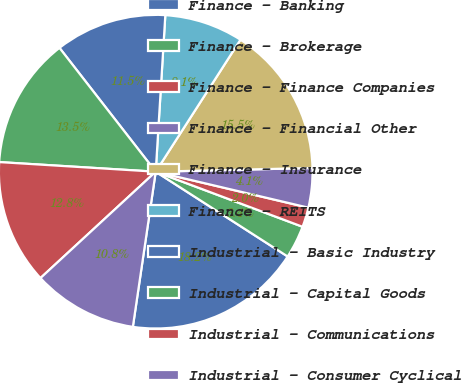<chart> <loc_0><loc_0><loc_500><loc_500><pie_chart><fcel>Finance - Banking<fcel>Finance - Brokerage<fcel>Finance - Finance Companies<fcel>Finance - Financial Other<fcel>Finance - Insurance<fcel>Finance - REITS<fcel>Industrial - Basic Industry<fcel>Industrial - Capital Goods<fcel>Industrial - Communications<fcel>Industrial - Consumer Cyclical<nl><fcel>18.24%<fcel>3.38%<fcel>2.03%<fcel>4.06%<fcel>15.54%<fcel>8.11%<fcel>11.49%<fcel>13.51%<fcel>12.84%<fcel>10.81%<nl></chart> 